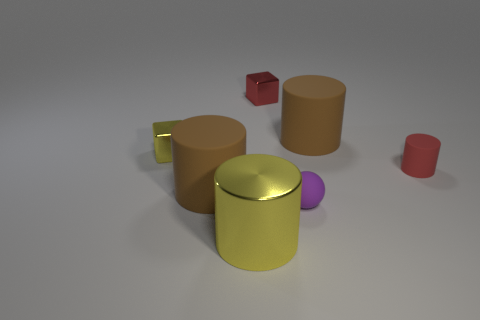Subtract all tiny red matte cylinders. How many cylinders are left? 3 Add 3 big blue rubber spheres. How many objects exist? 10 Subtract all purple cylinders. Subtract all gray cubes. How many cylinders are left? 4 Subtract all cylinders. How many objects are left? 3 Subtract 0 gray cylinders. How many objects are left? 7 Subtract all red cylinders. Subtract all small matte balls. How many objects are left? 5 Add 2 large shiny objects. How many large shiny objects are left? 3 Add 1 large brown metallic objects. How many large brown metallic objects exist? 1 